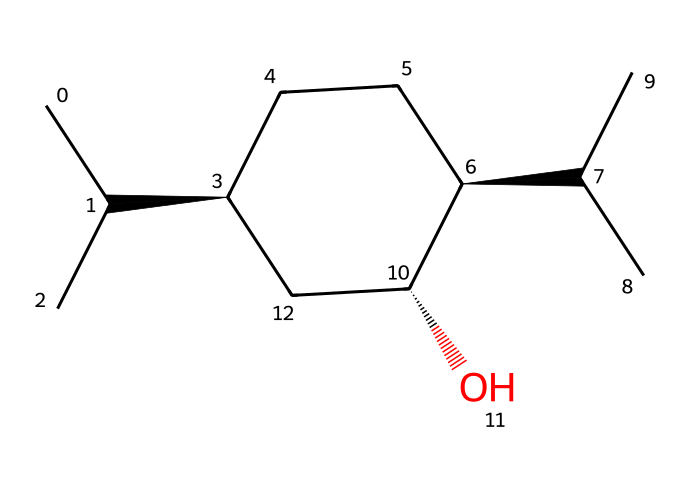What is the primary functional group in menthol? The structure includes a hydroxyl group (-OH), which is characteristic for alcohols, indicating that menthol is an alcohol.
Answer: hydroxyl group How many carbon atoms are in the menthol molecule? By examining the structure in the SMILES representation, there are 10 carbon atoms denoted by the "C" characters.
Answer: 10 How many chiral centers does menthol have? In the structure, there are three stereocenters indicated by the @ symbols, which denote the presence of chiral centers.
Answer: 3 What type of compound is menthol classified as? Given that menthol does not dissociate in water or produce ions, it is classified as a non-electrolyte.
Answer: non-electrolyte What is the molecular formula for menthol based on the structure? From the atoms counted in the structure, the molecular formula derived is C10H20O.
Answer: C10H20O Does menthol exhibit hydrogen bonding? The presence of the hydroxyl group in menthol allows for hydrogen bonding interactions with other molecules, which is a property of alcohols.
Answer: Yes 